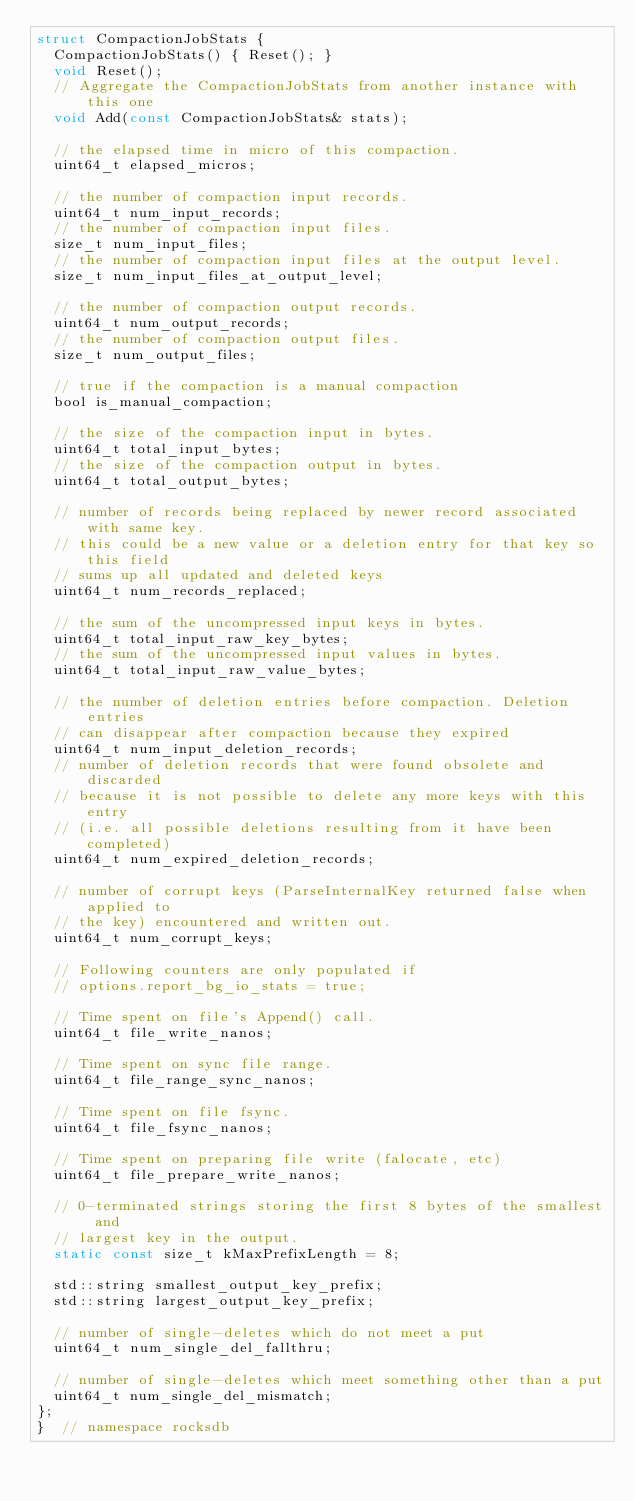<code> <loc_0><loc_0><loc_500><loc_500><_C_>struct CompactionJobStats {
  CompactionJobStats() { Reset(); }
  void Reset();
  // Aggregate the CompactionJobStats from another instance with this one
  void Add(const CompactionJobStats& stats);

  // the elapsed time in micro of this compaction.
  uint64_t elapsed_micros;

  // the number of compaction input records.
  uint64_t num_input_records;
  // the number of compaction input files.
  size_t num_input_files;
  // the number of compaction input files at the output level.
  size_t num_input_files_at_output_level;

  // the number of compaction output records.
  uint64_t num_output_records;
  // the number of compaction output files.
  size_t num_output_files;

  // true if the compaction is a manual compaction
  bool is_manual_compaction;

  // the size of the compaction input in bytes.
  uint64_t total_input_bytes;
  // the size of the compaction output in bytes.
  uint64_t total_output_bytes;

  // number of records being replaced by newer record associated with same key.
  // this could be a new value or a deletion entry for that key so this field
  // sums up all updated and deleted keys
  uint64_t num_records_replaced;

  // the sum of the uncompressed input keys in bytes.
  uint64_t total_input_raw_key_bytes;
  // the sum of the uncompressed input values in bytes.
  uint64_t total_input_raw_value_bytes;

  // the number of deletion entries before compaction. Deletion entries
  // can disappear after compaction because they expired
  uint64_t num_input_deletion_records;
  // number of deletion records that were found obsolete and discarded
  // because it is not possible to delete any more keys with this entry
  // (i.e. all possible deletions resulting from it have been completed)
  uint64_t num_expired_deletion_records;

  // number of corrupt keys (ParseInternalKey returned false when applied to
  // the key) encountered and written out.
  uint64_t num_corrupt_keys;

  // Following counters are only populated if
  // options.report_bg_io_stats = true;

  // Time spent on file's Append() call.
  uint64_t file_write_nanos;

  // Time spent on sync file range.
  uint64_t file_range_sync_nanos;

  // Time spent on file fsync.
  uint64_t file_fsync_nanos;

  // Time spent on preparing file write (falocate, etc)
  uint64_t file_prepare_write_nanos;

  // 0-terminated strings storing the first 8 bytes of the smallest and
  // largest key in the output.
  static const size_t kMaxPrefixLength = 8;

  std::string smallest_output_key_prefix;
  std::string largest_output_key_prefix;

  // number of single-deletes which do not meet a put
  uint64_t num_single_del_fallthru;

  // number of single-deletes which meet something other than a put
  uint64_t num_single_del_mismatch;
};
}  // namespace rocksdb
</code> 